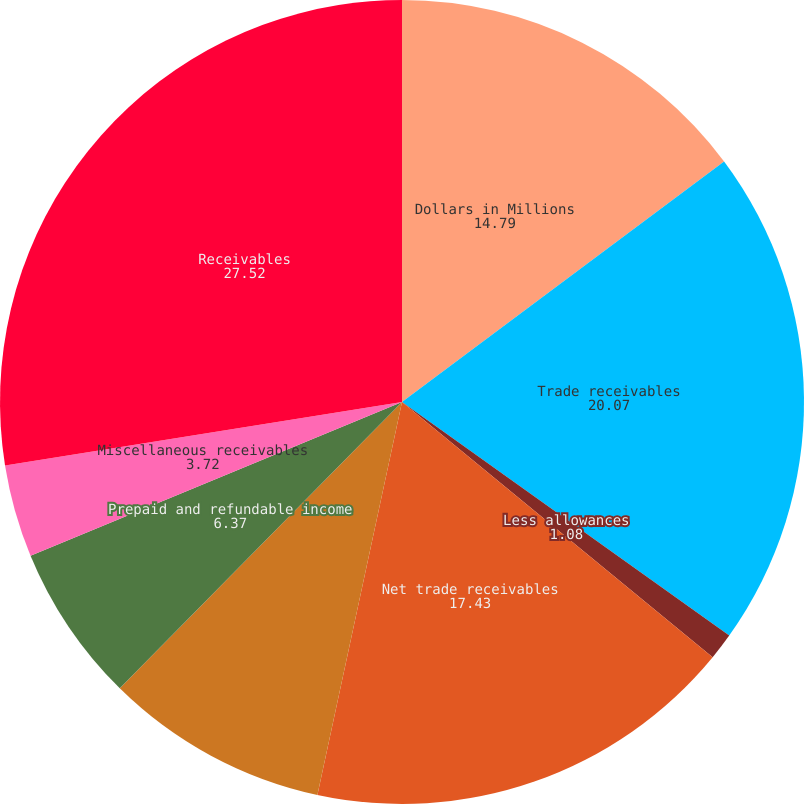<chart> <loc_0><loc_0><loc_500><loc_500><pie_chart><fcel>Dollars in Millions<fcel>Trade receivables<fcel>Less allowances<fcel>Net trade receivables<fcel>Alliance partners receivables<fcel>Prepaid and refundable income<fcel>Miscellaneous receivables<fcel>Receivables<nl><fcel>14.79%<fcel>20.07%<fcel>1.08%<fcel>17.43%<fcel>9.01%<fcel>6.37%<fcel>3.72%<fcel>27.52%<nl></chart> 